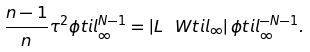<formula> <loc_0><loc_0><loc_500><loc_500>\frac { n - 1 } { n } \tau ^ { 2 } \phi t i l _ { \infty } ^ { N - 1 } = \left | L \ W t i l _ { \infty } \right | \phi t i l _ { \infty } ^ { - N - 1 } .</formula> 